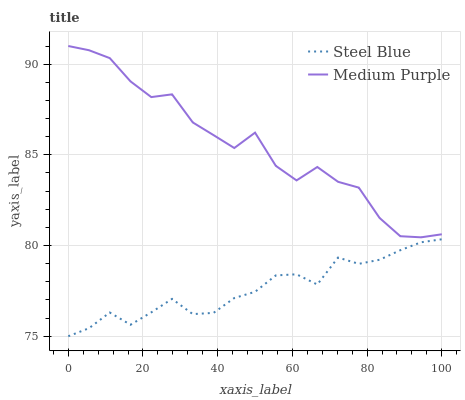Does Steel Blue have the maximum area under the curve?
Answer yes or no. No. Is Steel Blue the roughest?
Answer yes or no. No. Does Steel Blue have the highest value?
Answer yes or no. No. Is Steel Blue less than Medium Purple?
Answer yes or no. Yes. Is Medium Purple greater than Steel Blue?
Answer yes or no. Yes. Does Steel Blue intersect Medium Purple?
Answer yes or no. No. 